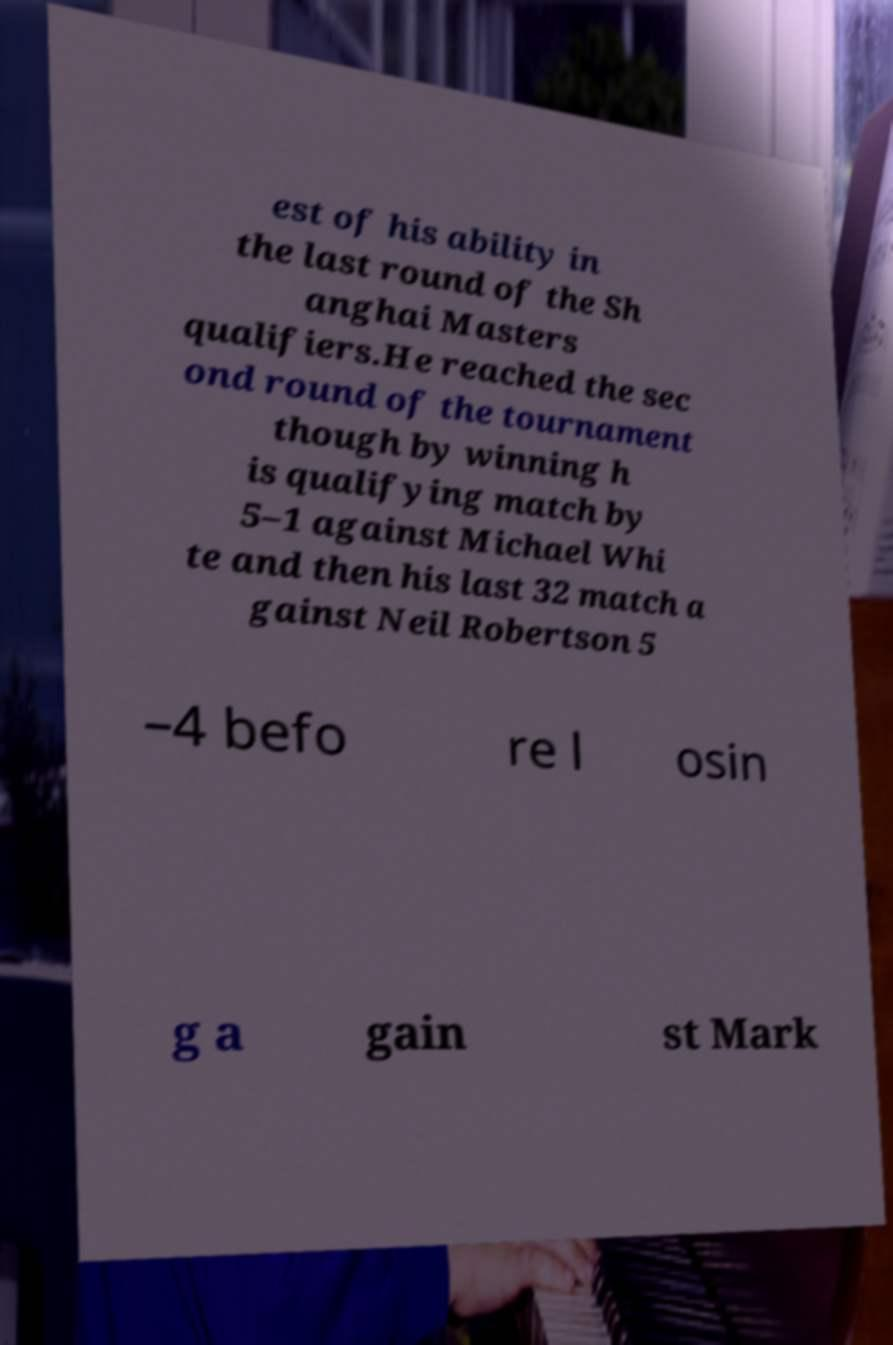Could you assist in decoding the text presented in this image and type it out clearly? est of his ability in the last round of the Sh anghai Masters qualifiers.He reached the sec ond round of the tournament though by winning h is qualifying match by 5–1 against Michael Whi te and then his last 32 match a gainst Neil Robertson 5 –4 befo re l osin g a gain st Mark 